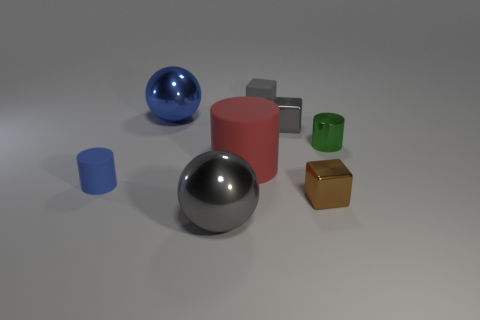Is there any indication of the purpose of these objects or how they might be used? The objects in the image appear to be simple geometric shapes and do not provide clear indications of a specific purpose or use. They might be used for a variety of purposes depending on the context, such as educational tools for teaching geometry or as props for a visual composition study in photography. 